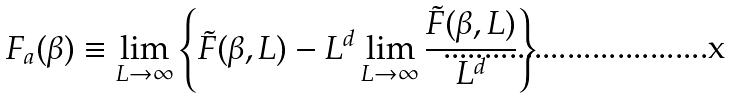Convert formula to latex. <formula><loc_0><loc_0><loc_500><loc_500>F _ { a } ( \beta ) \equiv \lim _ { L \rightarrow \infty } \left \{ \tilde { F } ( \beta , L ) - L ^ { d } \lim _ { L \rightarrow \infty } \frac { \tilde { F } ( \beta , L ) } { L ^ { d } } \right \}</formula> 